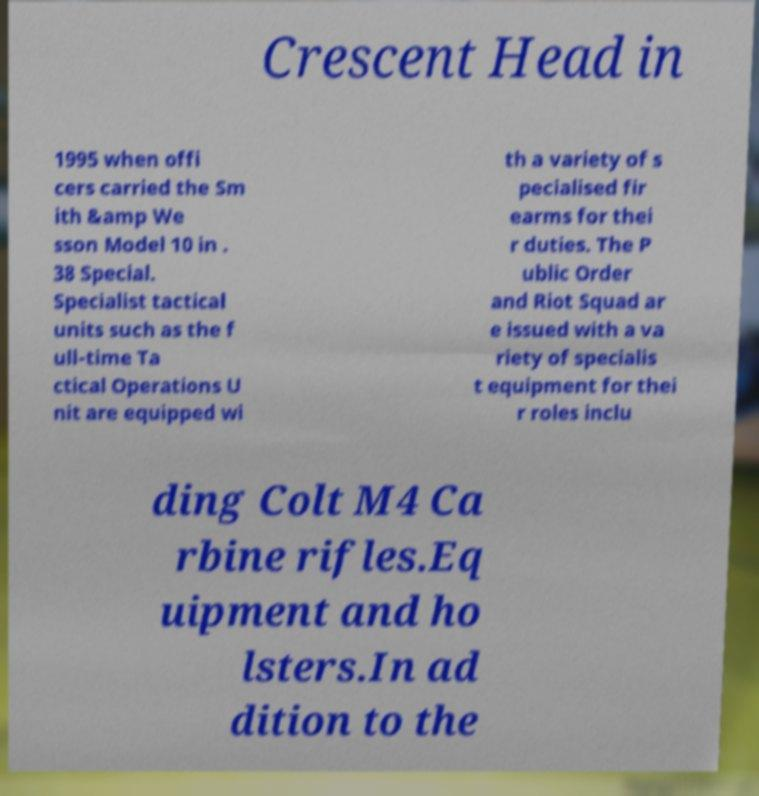Can you accurately transcribe the text from the provided image for me? Crescent Head in 1995 when offi cers carried the Sm ith &amp We sson Model 10 in . 38 Special. Specialist tactical units such as the f ull-time Ta ctical Operations U nit are equipped wi th a variety of s pecialised fir earms for thei r duties. The P ublic Order and Riot Squad ar e issued with a va riety of specialis t equipment for thei r roles inclu ding Colt M4 Ca rbine rifles.Eq uipment and ho lsters.In ad dition to the 